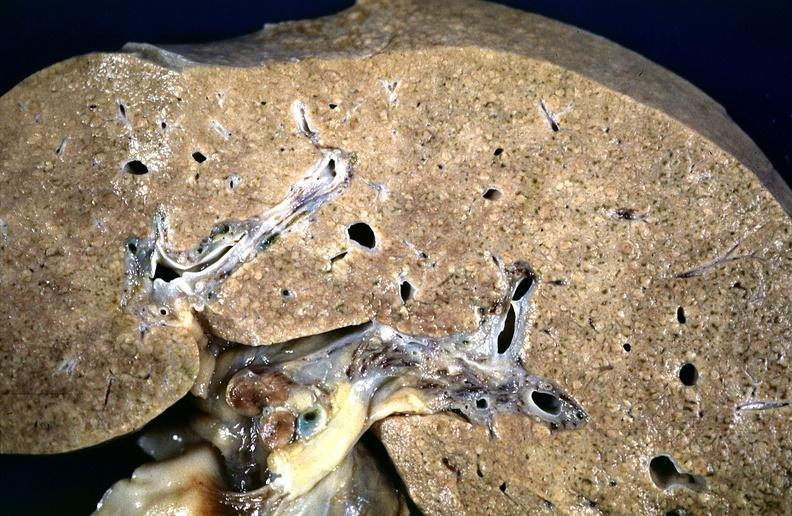s hepatobiliary present?
Answer the question using a single word or phrase. Yes 